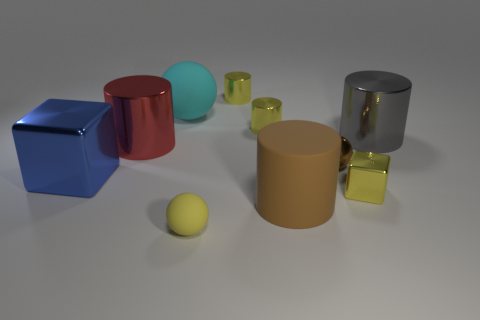Subtract all cyan spheres. How many yellow cylinders are left? 2 Subtract 1 spheres. How many spheres are left? 2 Subtract all cyan spheres. How many spheres are left? 2 Subtract all red cylinders. How many cylinders are left? 4 Subtract all brown cylinders. Subtract all cyan spheres. How many cylinders are left? 4 Subtract all blocks. How many objects are left? 8 Subtract all large spheres. Subtract all blue objects. How many objects are left? 8 Add 4 tiny yellow shiny blocks. How many tiny yellow shiny blocks are left? 5 Add 3 big gray metal things. How many big gray metal things exist? 4 Subtract 1 brown spheres. How many objects are left? 9 